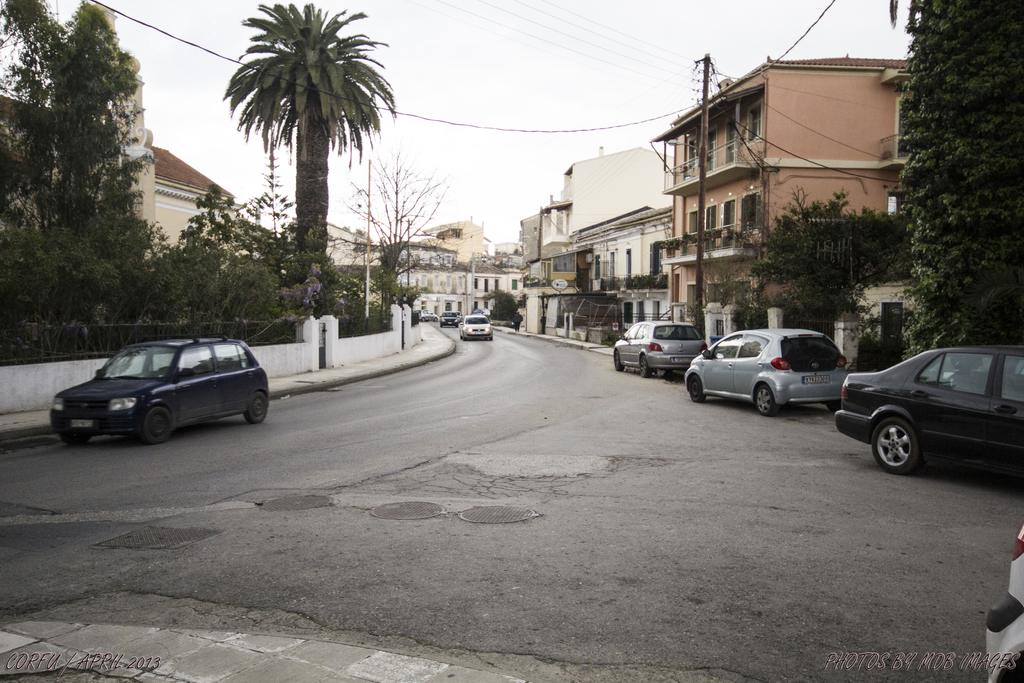What can be seen moving on the road in the image? There are vehicles on the road in the image. Are there any parked vehicles in the image? Yes, cars are parked in the image. What type of vegetation is present on either side of the road? There are trees on either side of the road in the image. What type of structures can be seen on either side of the road? There are buildings on either side of the road in the image. What can be seen above the road in the image? There are poles and wires on the top of the road in the image. Can you see a tramp performing tricks on the road in the image? No, there is no tramp performing tricks on the road in the image. What color is the needle used by the person walking on the road in the image? There is no person walking on the road, nor is there a needle present in the image. 